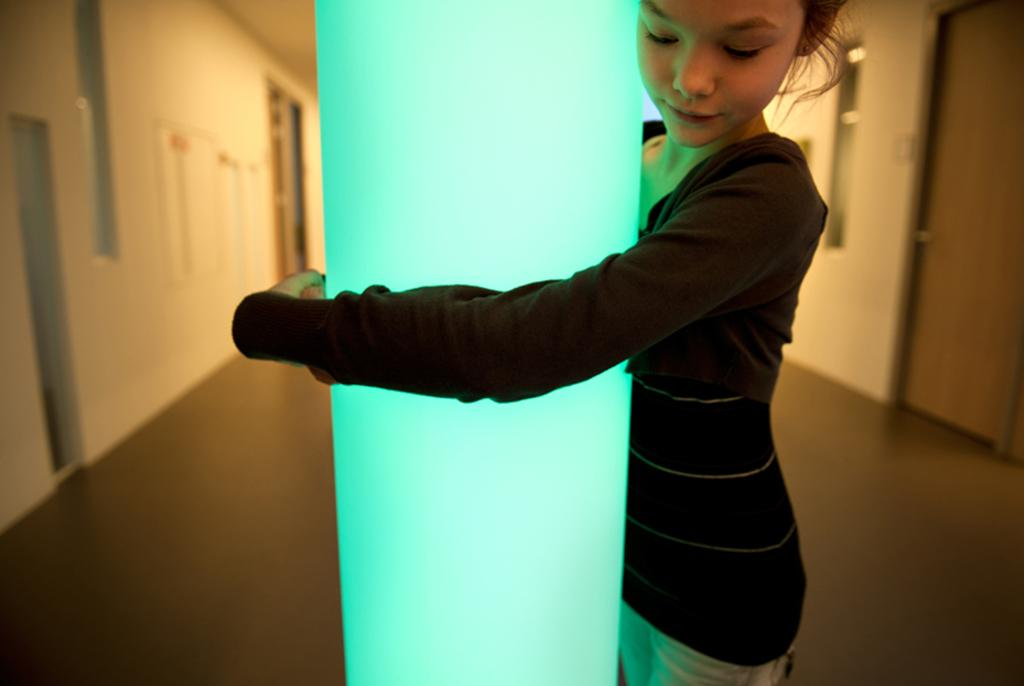Who is the main subject in the image? There is a girl in the image. What is the girl doing in the image? The girl is holding a pillar with her hands. Can you describe the setting of the image? The image appears to be an inner view of a house. What type of sleet can be seen falling outside the house in the image? There is no sleet visible in the image, as it is an inner view of a house. 